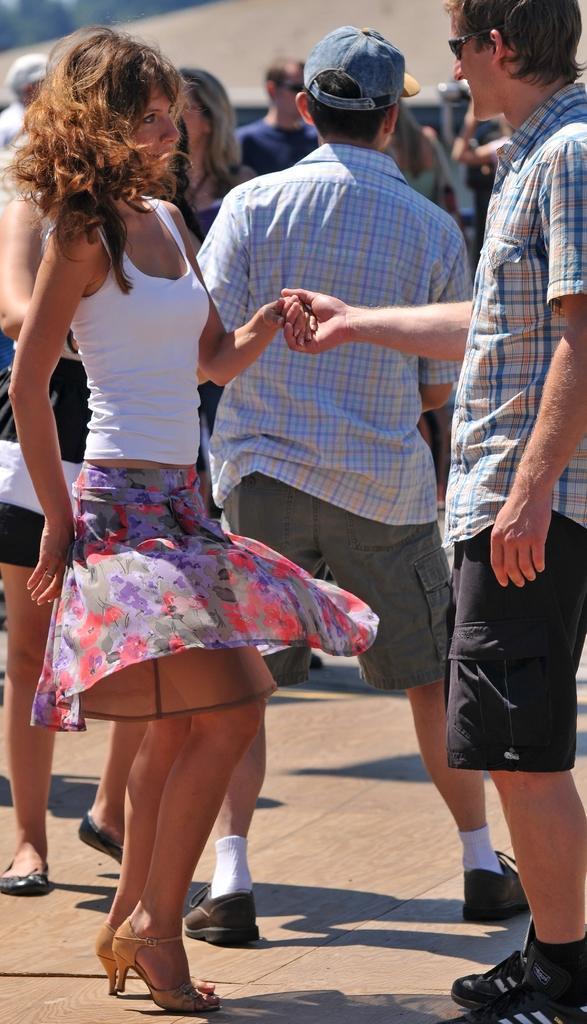Describe this image in one or two sentences. In the picture there is a woman and a man standing, beside them there are many people present, there may be a vehicle. 